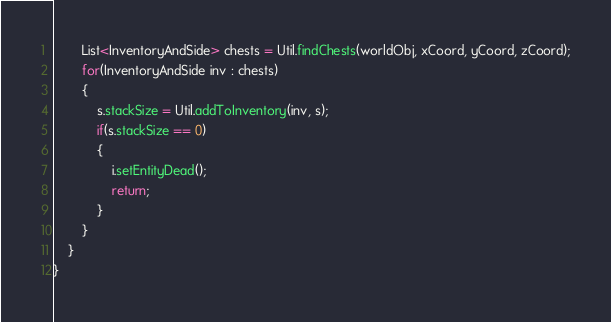Convert code to text. <code><loc_0><loc_0><loc_500><loc_500><_Java_>		List<InventoryAndSide> chests = Util.findChests(worldObj, xCoord, yCoord, zCoord);
		for(InventoryAndSide inv : chests)
		{
			s.stackSize = Util.addToInventory(inv, s);
			if(s.stackSize == 0)
			{
				i.setEntityDead();
				return;
			}
		}
	}
}
</code> 